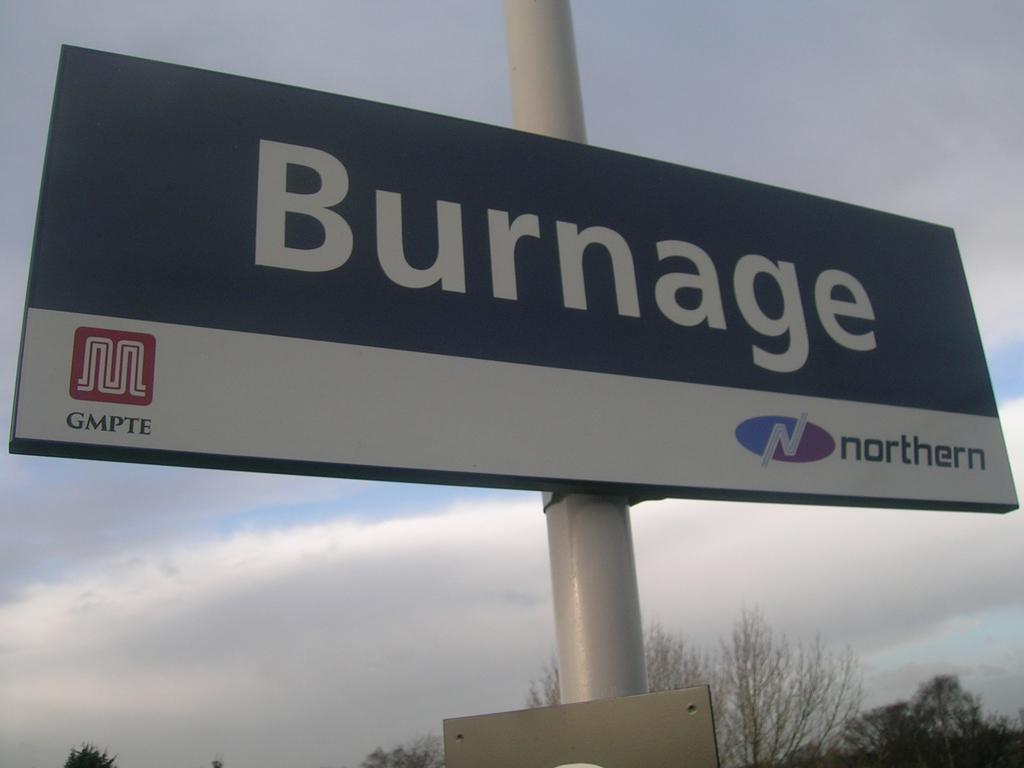<image>
Create a compact narrative representing the image presented. A Burnage billboard is posted on a large white pole. 